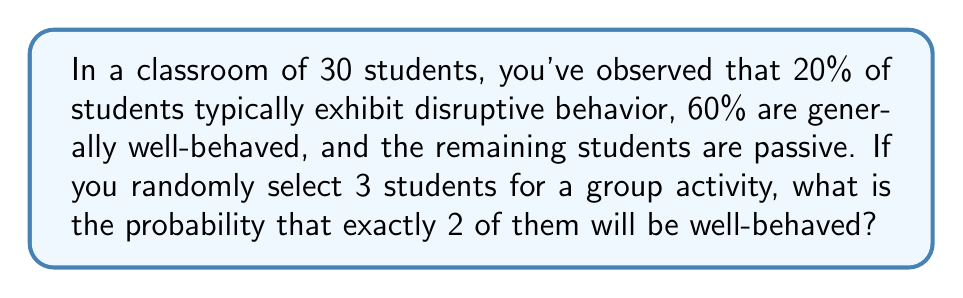Show me your answer to this math problem. To solve this problem, we'll use the concept of probability and the binomial probability formula. Let's break it down step-by-step:

1. Identify the probabilities:
   - Well-behaved students: 60% = 0.6
   - Not well-behaved students: 40% = 0.4

2. We're selecting 3 students, and we want exactly 2 to be well-behaved. This scenario follows a binomial distribution.

3. The binomial probability formula is:

   $$ P(X = k) = \binom{n}{k} p^k (1-p)^{n-k} $$

   Where:
   $n$ = number of trials (students selected) = 3
   $k$ = number of successes (well-behaved students) = 2
   $p$ = probability of success (probability of selecting a well-behaved student) = 0.6

4. Let's calculate each part:

   $\binom{n}{k} = \binom{3}{2} = \frac{3!}{2!(3-2)!} = \frac{3 \cdot 2 \cdot 1}{(2 \cdot 1)(1)} = 3$

   $p^k = 0.6^2 = 0.36$

   $(1-p)^{n-k} = (1-0.6)^{3-2} = 0.4^1 = 0.4$

5. Now, let's put it all together:

   $$ P(X = 2) = 3 \cdot 0.36 \cdot 0.4 = 0.432 $$

Therefore, the probability of selecting exactly 2 well-behaved students out of 3 randomly chosen students is 0.432 or 43.2%.
Answer: 0.432 or 43.2% 